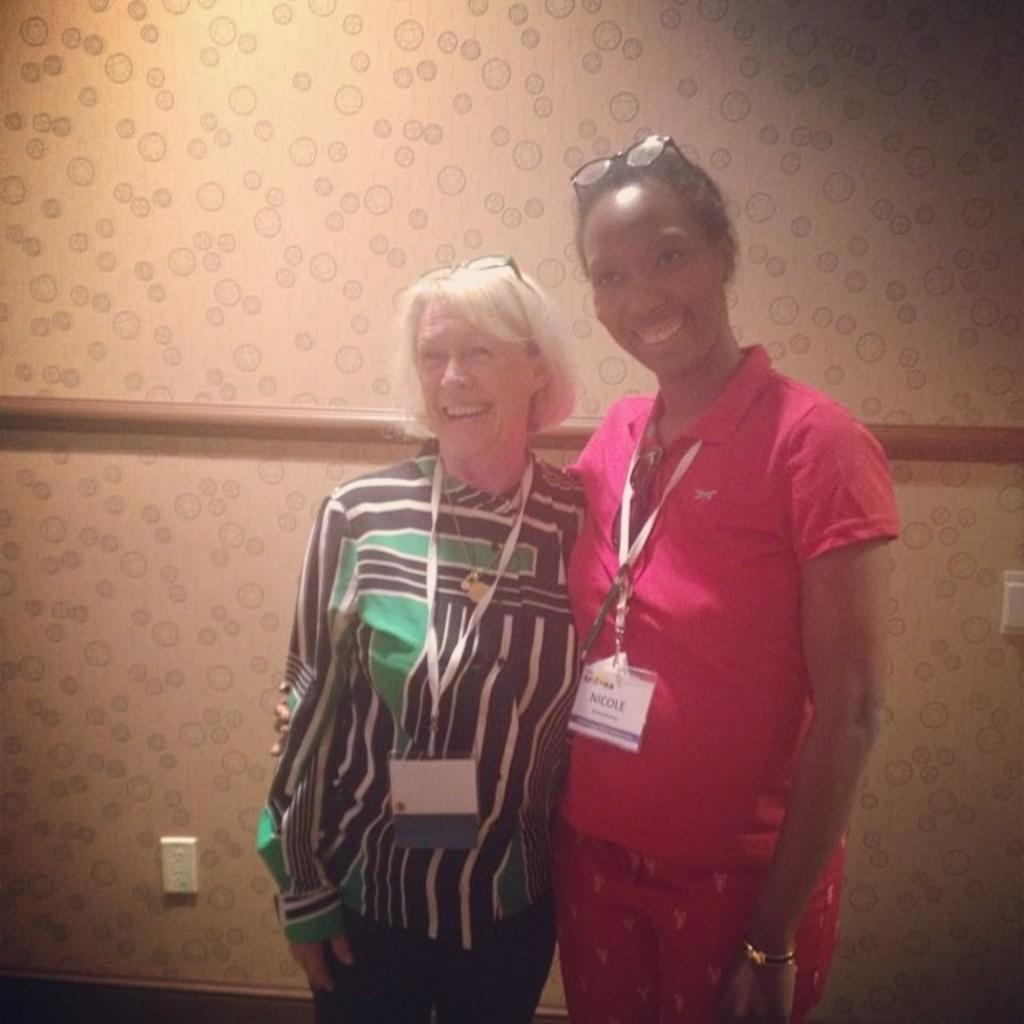How many people are in the image? There are two persons in the image. What expressions do the people have on their faces? The persons are wearing smiles on their faces. What can be seen in the background of the image? There is a wall in the background of the image. What is attached to the wall in the image? There is a switch board on the wall. What type of building is the persons seeking approval for in the image? There is no indication in the image that the persons are seeking approval for any building. 